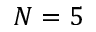<formula> <loc_0><loc_0><loc_500><loc_500>N = 5</formula> 